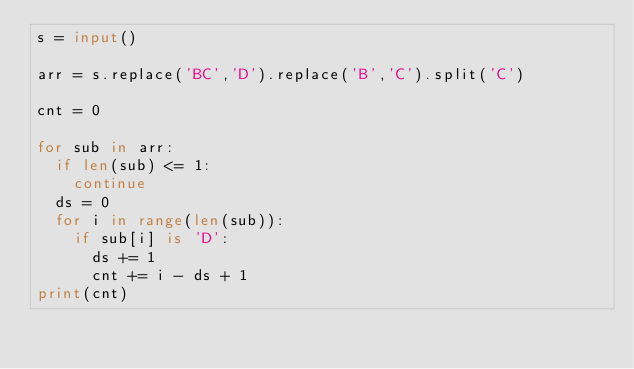<code> <loc_0><loc_0><loc_500><loc_500><_Python_>s = input()

arr = s.replace('BC','D').replace('B','C').split('C')

cnt = 0

for sub in arr:
  if len(sub) <= 1:
    continue
  ds = 0
  for i in range(len(sub)):
    if sub[i] is 'D':
      ds += 1
      cnt += i - ds + 1
print(cnt)
      </code> 